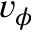Convert formula to latex. <formula><loc_0><loc_0><loc_500><loc_500>v _ { \phi }</formula> 